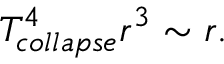Convert formula to latex. <formula><loc_0><loc_0><loc_500><loc_500>T _ { c o l l a p s e } ^ { 4 } r ^ { 3 } \sim r .</formula> 